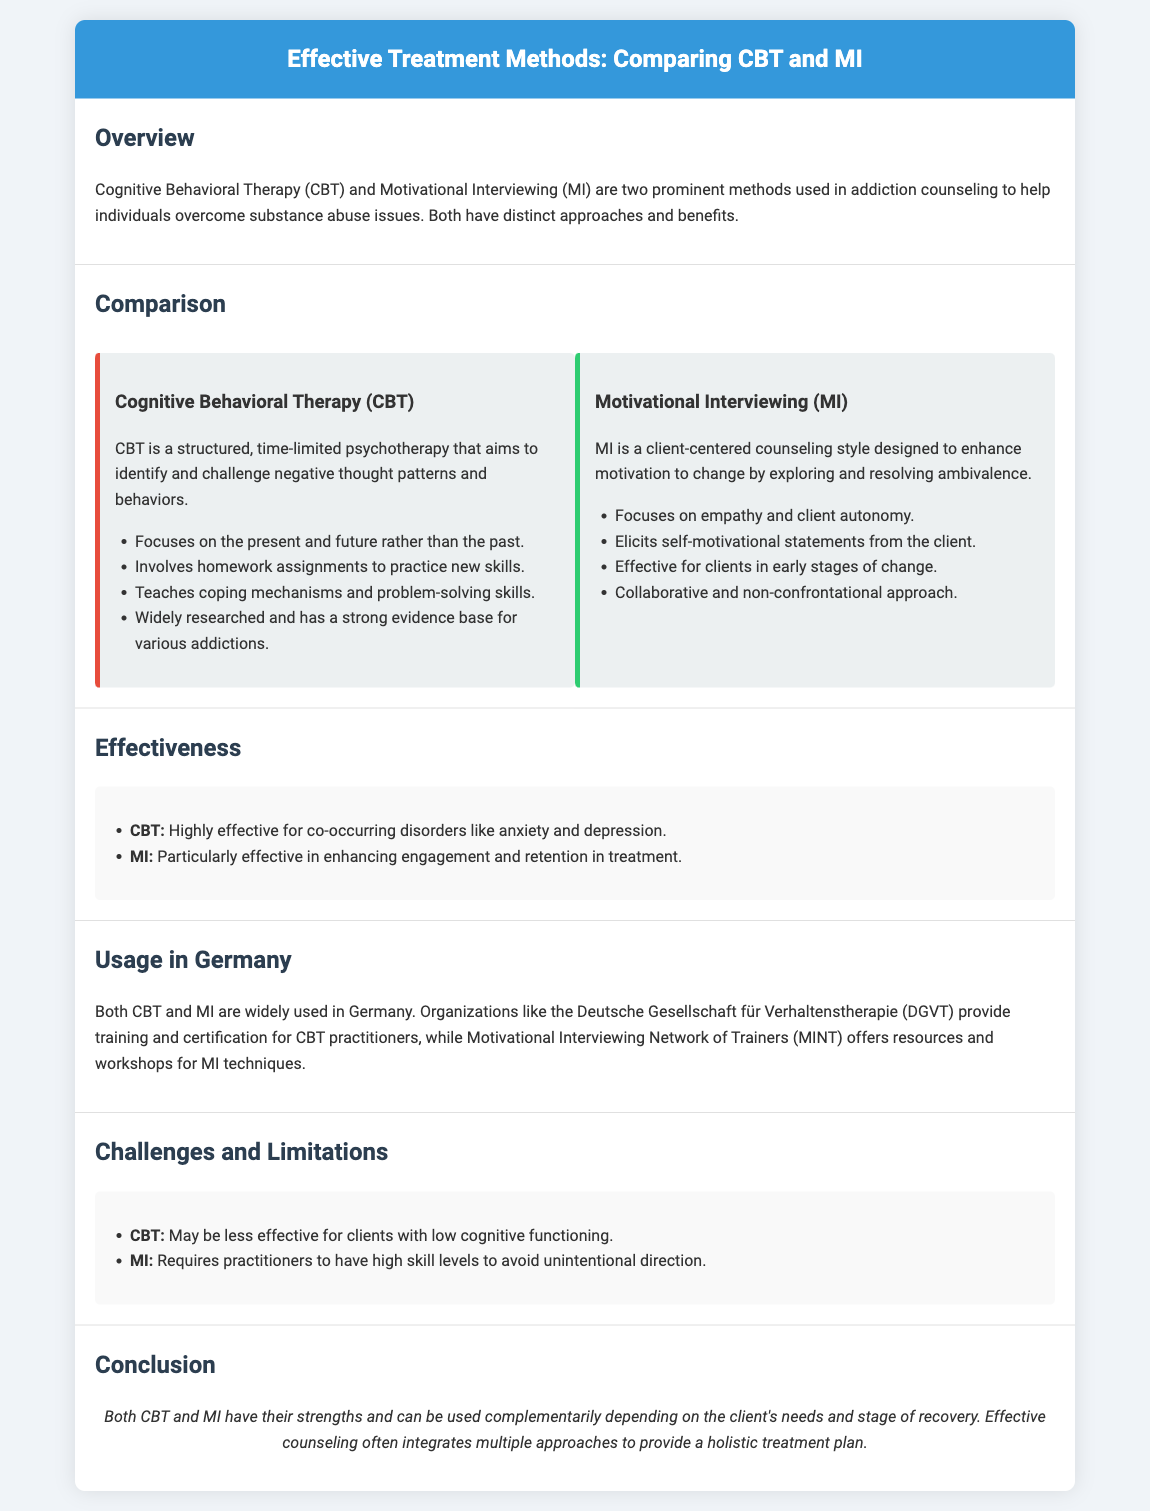What is the primary focus of Cognitive Behavioral Therapy (CBT)? CBT primarily focuses on identifying and challenging negative thought patterns and behaviors.
Answer: Negative thought patterns and behaviors What does Motivational Interviewing (MI) emphasize? MI emphasizes empathy and client autonomy as a key part of the counseling style.
Answer: Empathy and client autonomy What is a significant strength of CBT according to the document? CBT is highly effective for co-occurring disorders like anxiety and depression.
Answer: Co-occurring disorders Which organization provides training for CBT practitioners in Germany? The Deutsche Gesellschaft für Verhaltenstherapie (DGVT) provides training and certification for CBT practitioners.
Answer: Deutsche Gesellschaft für Verhaltenstherapie (DGVT) What is a limitation of CBT mentioned in the document? A limitation of CBT is that it may be less effective for clients with low cognitive functioning.
Answer: Low cognitive functioning What does MI aim to enhance in clients? MI aims to enhance motivation to change by exploring and resolving ambivalence.
Answer: Motivation to change Which treatment method is mentioned as particularly effective in enhancing engagement? Motivational Interviewing (MI) is particularly effective in enhancing engagement and retention in treatment.
Answer: Motivational Interviewing (MI) What kind of approach does MI use? MI employs a collaborative and non-confrontational approach with clients.
Answer: Collaborative and non-confrontational What is the purpose of homework assignments in CBT? Homework assignments in CBT are used to practice new skills learned during therapy sessions.
Answer: Practice new skills 